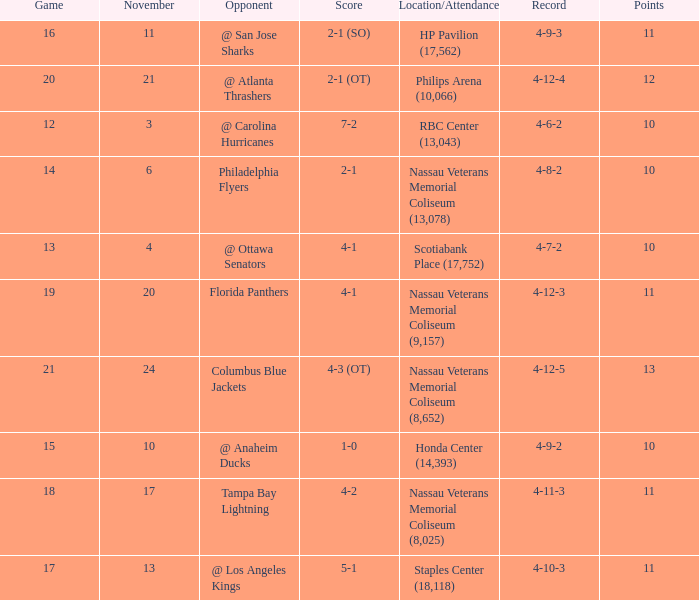What is the highest entry in November for the game 20? 21.0. 